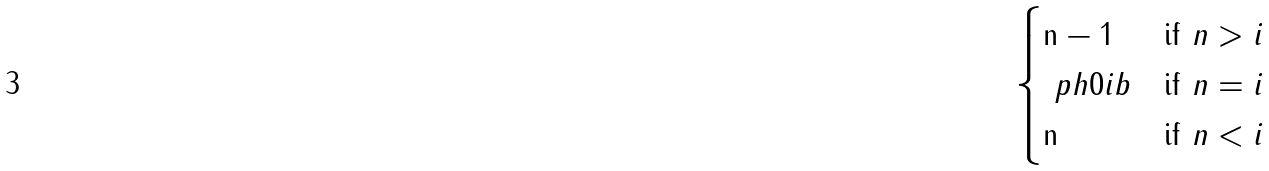<formula> <loc_0><loc_0><loc_500><loc_500>\begin{cases} { \tt n - 1 } & \text {if $n > i$} \\ \ p h { 0 } { i } b & \text {if $n = i$} \\ { \tt n } & \text {if $n < i$} \end{cases}</formula> 